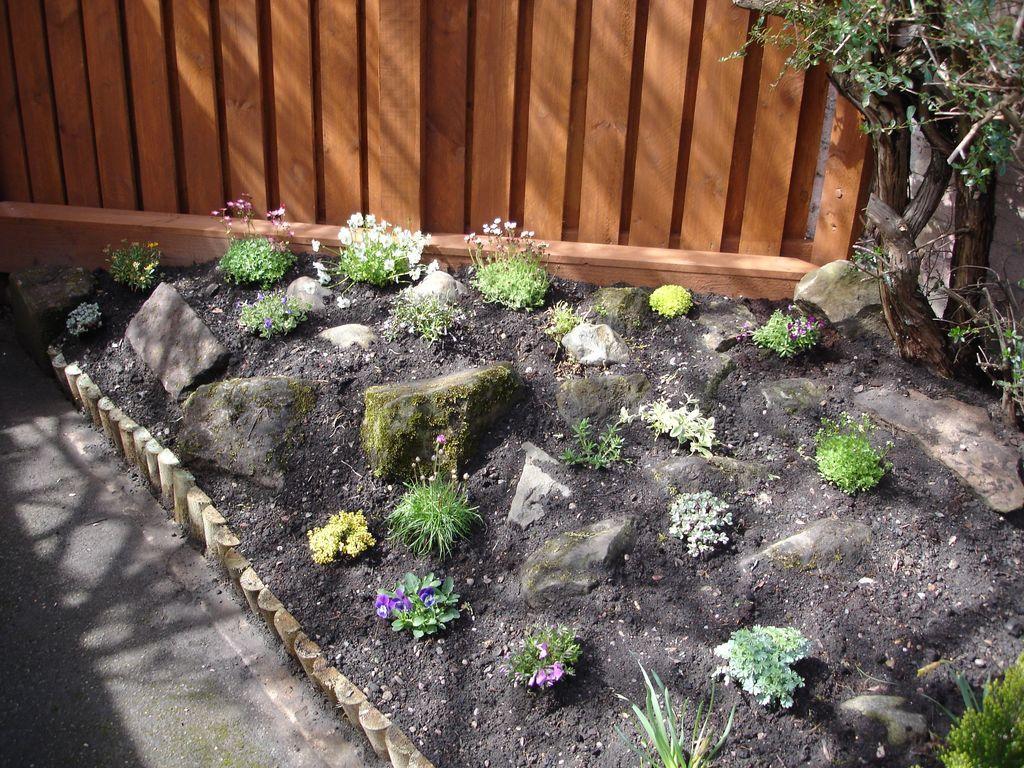Please provide a concise description of this image. In this picture we can see plants with flowers and stones on the ground. In the background we can see a tree and the wall. 